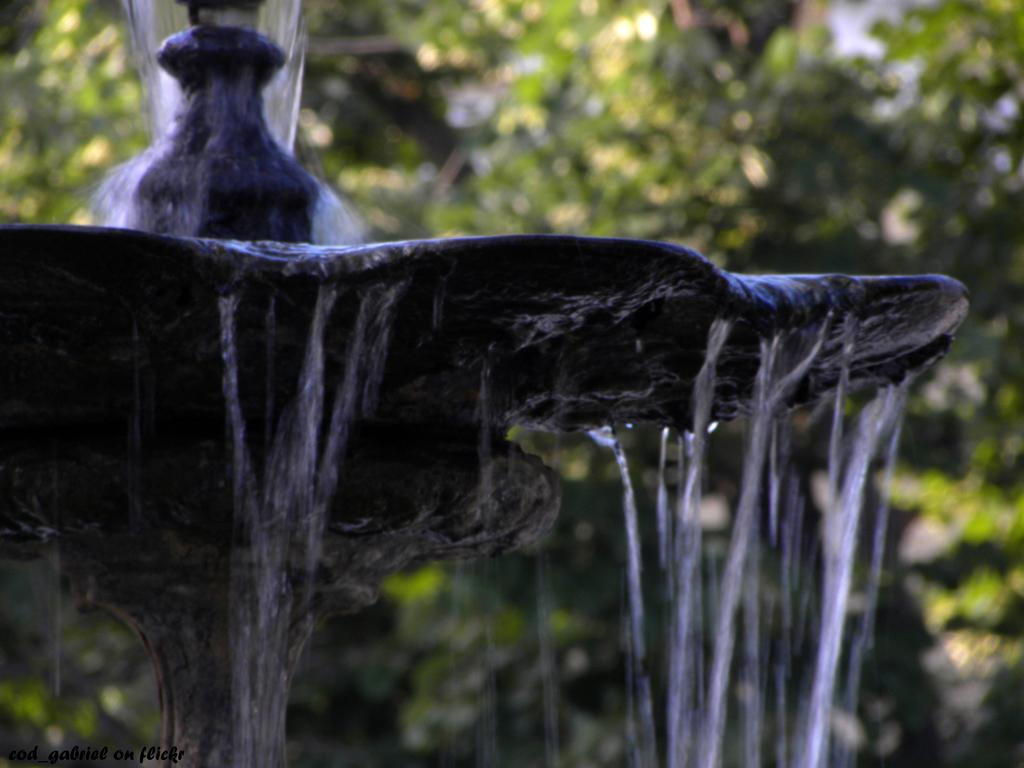What is the main feature in the image? There is a fountain in the image. What is flowing from the fountain? There is water in the image. What can be seen in the background of the image? There are trees in the background of the image. What type of cloth is draped over the fountain in the image? There is no cloth draped over the fountain in the image. How does the fountain contribute to the death of the person in the image? There is no person in the image, and the fountain does not contribute to any death. 